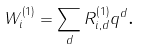Convert formula to latex. <formula><loc_0><loc_0><loc_500><loc_500>W _ { i } ^ { \left ( 1 \right ) } = \sum _ { d } R _ { i , d } ^ { \left ( 1 \right ) } q ^ { d } \text {.}</formula> 